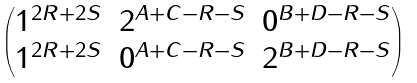Convert formula to latex. <formula><loc_0><loc_0><loc_500><loc_500>\begin{pmatrix} 1 ^ { 2 R + 2 S } & 2 ^ { A + C - R - S } & 0 ^ { B + D - R - S } \\ 1 ^ { 2 R + 2 S } & 0 ^ { A + C - R - S } & 2 ^ { B + D - R - S } \end{pmatrix}</formula> 